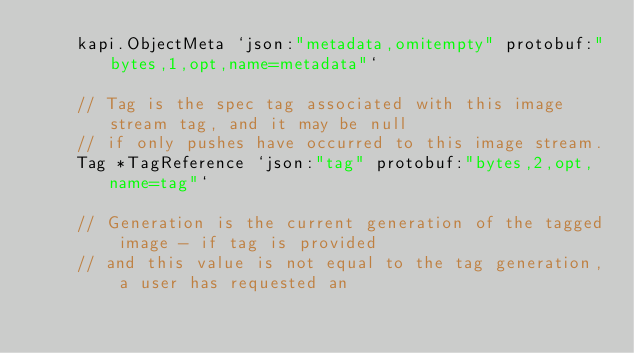Convert code to text. <code><loc_0><loc_0><loc_500><loc_500><_Go_>	kapi.ObjectMeta `json:"metadata,omitempty" protobuf:"bytes,1,opt,name=metadata"`

	// Tag is the spec tag associated with this image stream tag, and it may be null
	// if only pushes have occurred to this image stream.
	Tag *TagReference `json:"tag" protobuf:"bytes,2,opt,name=tag"`

	// Generation is the current generation of the tagged image - if tag is provided
	// and this value is not equal to the tag generation, a user has requested an</code> 